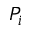<formula> <loc_0><loc_0><loc_500><loc_500>P _ { i }</formula> 